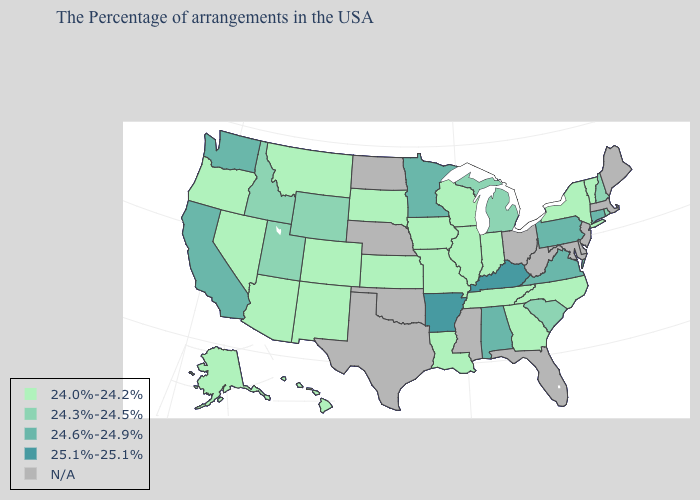Which states have the highest value in the USA?
Keep it brief. Kentucky, Arkansas. What is the value of Kentucky?
Short answer required. 25.1%-25.1%. What is the value of Oregon?
Keep it brief. 24.0%-24.2%. Which states have the lowest value in the Northeast?
Concise answer only. Vermont, New York. Name the states that have a value in the range 25.1%-25.1%?
Concise answer only. Kentucky, Arkansas. Name the states that have a value in the range N/A?
Give a very brief answer. Maine, Massachusetts, New Jersey, Delaware, Maryland, West Virginia, Ohio, Florida, Mississippi, Nebraska, Oklahoma, Texas, North Dakota. What is the lowest value in states that border Illinois?
Write a very short answer. 24.0%-24.2%. What is the highest value in states that border Kansas?
Concise answer only. 24.0%-24.2%. Name the states that have a value in the range 24.0%-24.2%?
Answer briefly. Vermont, New York, North Carolina, Georgia, Indiana, Tennessee, Wisconsin, Illinois, Louisiana, Missouri, Iowa, Kansas, South Dakota, Colorado, New Mexico, Montana, Arizona, Nevada, Oregon, Alaska, Hawaii. Name the states that have a value in the range 24.6%-24.9%?
Give a very brief answer. Connecticut, Pennsylvania, Virginia, Alabama, Minnesota, California, Washington. What is the value of New Mexico?
Be succinct. 24.0%-24.2%. How many symbols are there in the legend?
Be succinct. 5. Name the states that have a value in the range 25.1%-25.1%?
Write a very short answer. Kentucky, Arkansas. What is the value of New Mexico?
Give a very brief answer. 24.0%-24.2%. What is the value of Arizona?
Answer briefly. 24.0%-24.2%. 